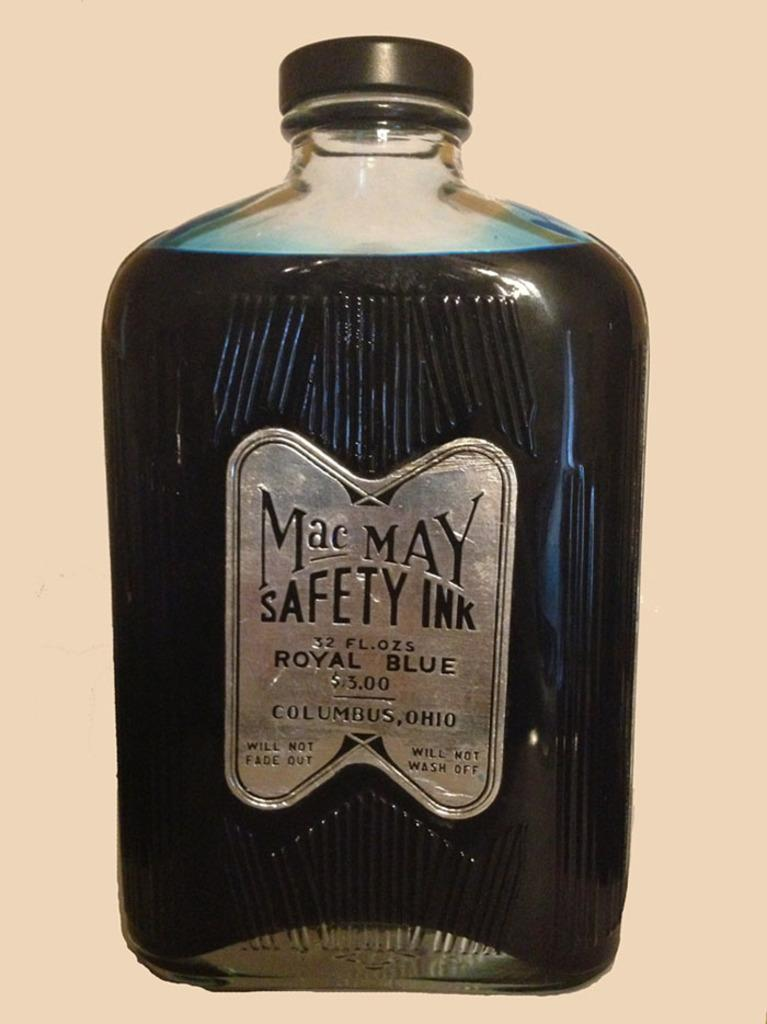<image>
Give a short and clear explanation of the subsequent image. A bottle of royal blue ink from the brand Mac May. 